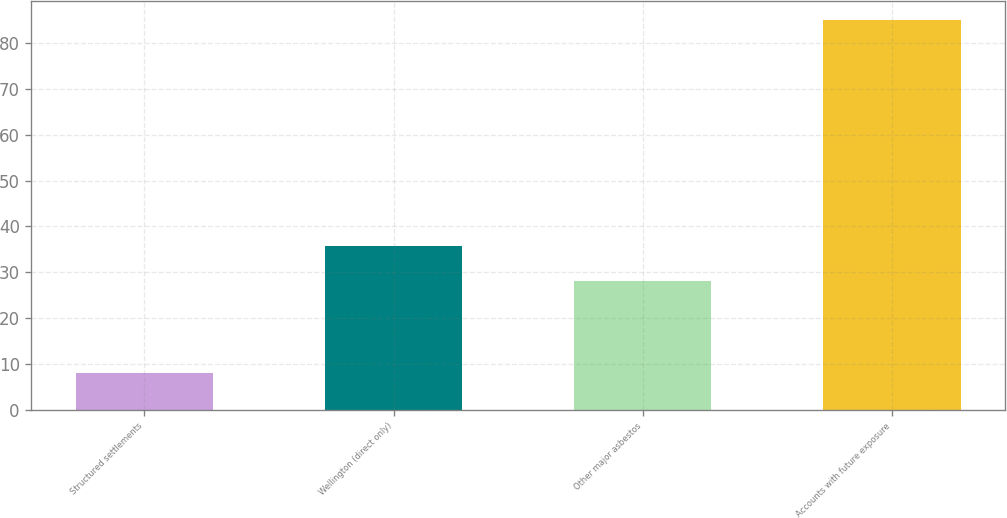<chart> <loc_0><loc_0><loc_500><loc_500><bar_chart><fcel>Structured settlements<fcel>Wellington (direct only)<fcel>Other major asbestos<fcel>Accounts with future exposure<nl><fcel>8<fcel>35.7<fcel>28<fcel>85<nl></chart> 